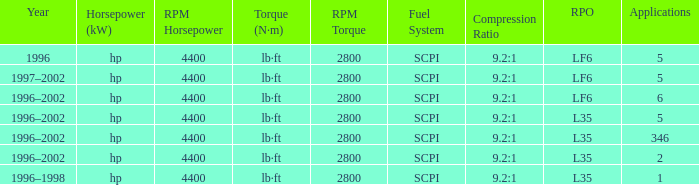What's the compression ratio of the model with L35 RPO and 5 applications? 9.2:1. Can you give me this table as a dict? {'header': ['Year', 'Horsepower (kW)', 'RPM Horsepower', 'Torque (N·m)', 'RPM Torque', 'Fuel System', 'Compression Ratio', 'RPO', 'Applications'], 'rows': [['1996', 'hp', '4400', 'lb·ft', '2800', 'SCPI', '9.2:1', 'LF6', '5'], ['1997–2002', 'hp', '4400', 'lb·ft', '2800', 'SCPI', '9.2:1', 'LF6', '5'], ['1996–2002', 'hp', '4400', 'lb·ft', '2800', 'SCPI', '9.2:1', 'LF6', '6'], ['1996–2002', 'hp', '4400', 'lb·ft', '2800', 'SCPI', '9.2:1', 'L35', '5'], ['1996–2002', 'hp', '4400', 'lb·ft', '2800', 'SCPI', '9.2:1', 'L35', '346'], ['1996–2002', 'hp', '4400', 'lb·ft', '2800', 'SCPI', '9.2:1', 'L35', '2'], ['1996–1998', 'hp', '4400', 'lb·ft', '2800', 'SCPI', '9.2:1', 'L35', '1']]} 